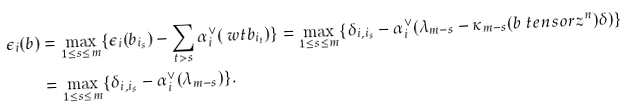<formula> <loc_0><loc_0><loc_500><loc_500>\epsilon _ { i } ( b ) & = \max _ { 1 \leq s \leq m } \{ \epsilon _ { i } ( b _ { i _ { s } } ) - \sum _ { t > s } \alpha _ { i } ^ { \vee } ( \ w t b _ { i _ { t } } ) \} = \max _ { 1 \leq s \leq m } \{ \delta _ { i , i _ { s } } - \alpha _ { i } ^ { \vee } ( \lambda _ { m - s } - \kappa _ { m - s } ( b \ t e n s o r z ^ { n } ) \delta ) \} \\ & = \max _ { 1 \leq s \leq m } \{ \delta _ { i , i _ { s } } - \alpha _ { i } ^ { \vee } ( \lambda _ { m - s } ) \} .</formula> 